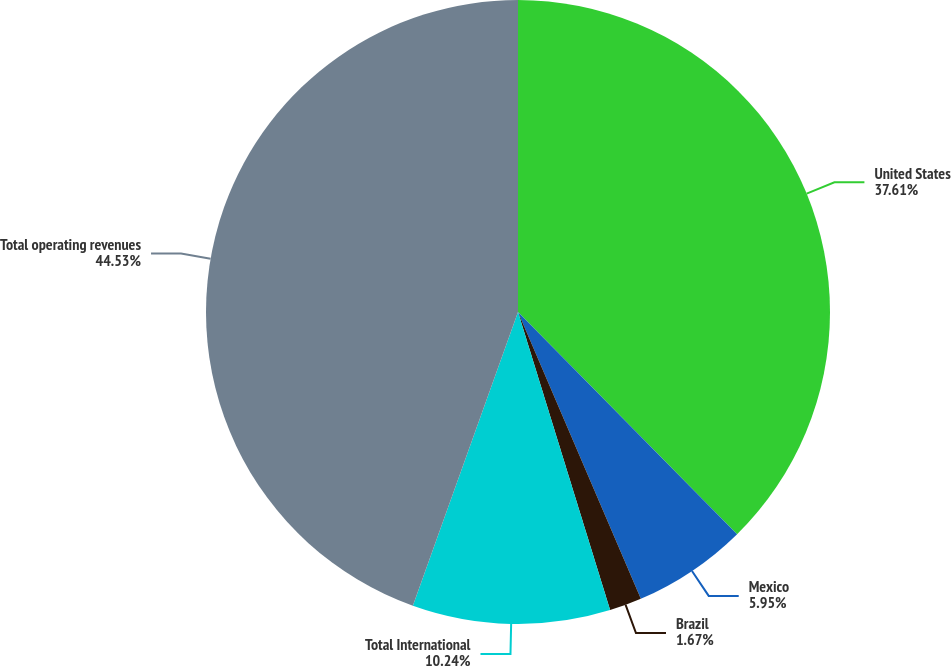Convert chart. <chart><loc_0><loc_0><loc_500><loc_500><pie_chart><fcel>United States<fcel>Mexico<fcel>Brazil<fcel>Total International<fcel>Total operating revenues<nl><fcel>37.61%<fcel>5.95%<fcel>1.67%<fcel>10.24%<fcel>44.53%<nl></chart> 